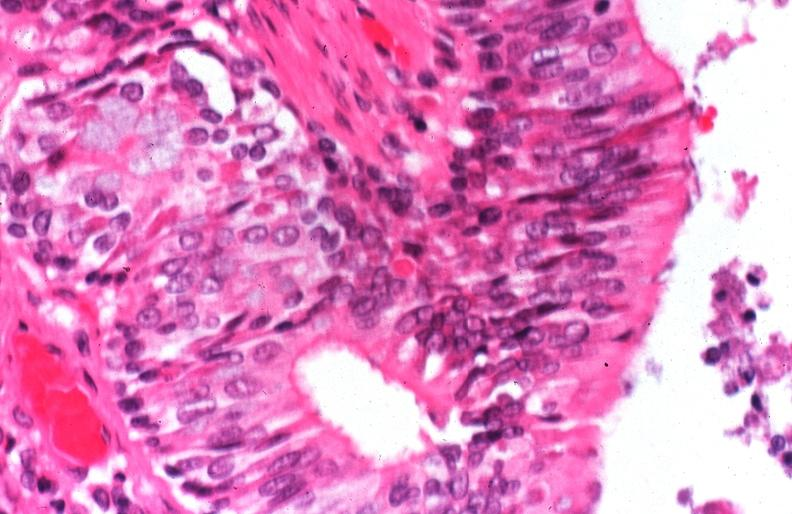where is this?
Answer the question using a single word or phrase. Lung 